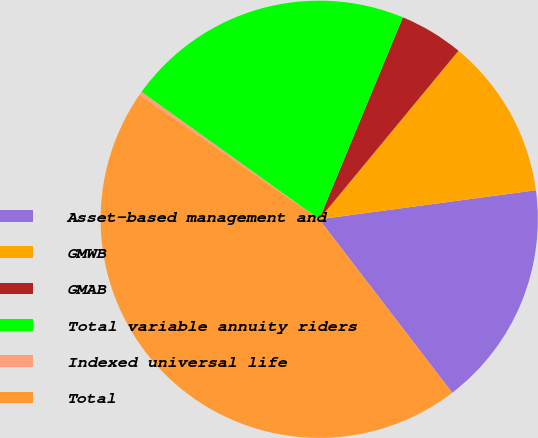<chart> <loc_0><loc_0><loc_500><loc_500><pie_chart><fcel>Asset-based management and<fcel>GMWB<fcel>GMAB<fcel>Total variable annuity riders<fcel>Indexed universal life<fcel>Total<nl><fcel>16.71%<fcel>11.89%<fcel>4.74%<fcel>21.36%<fcel>0.26%<fcel>45.05%<nl></chart> 